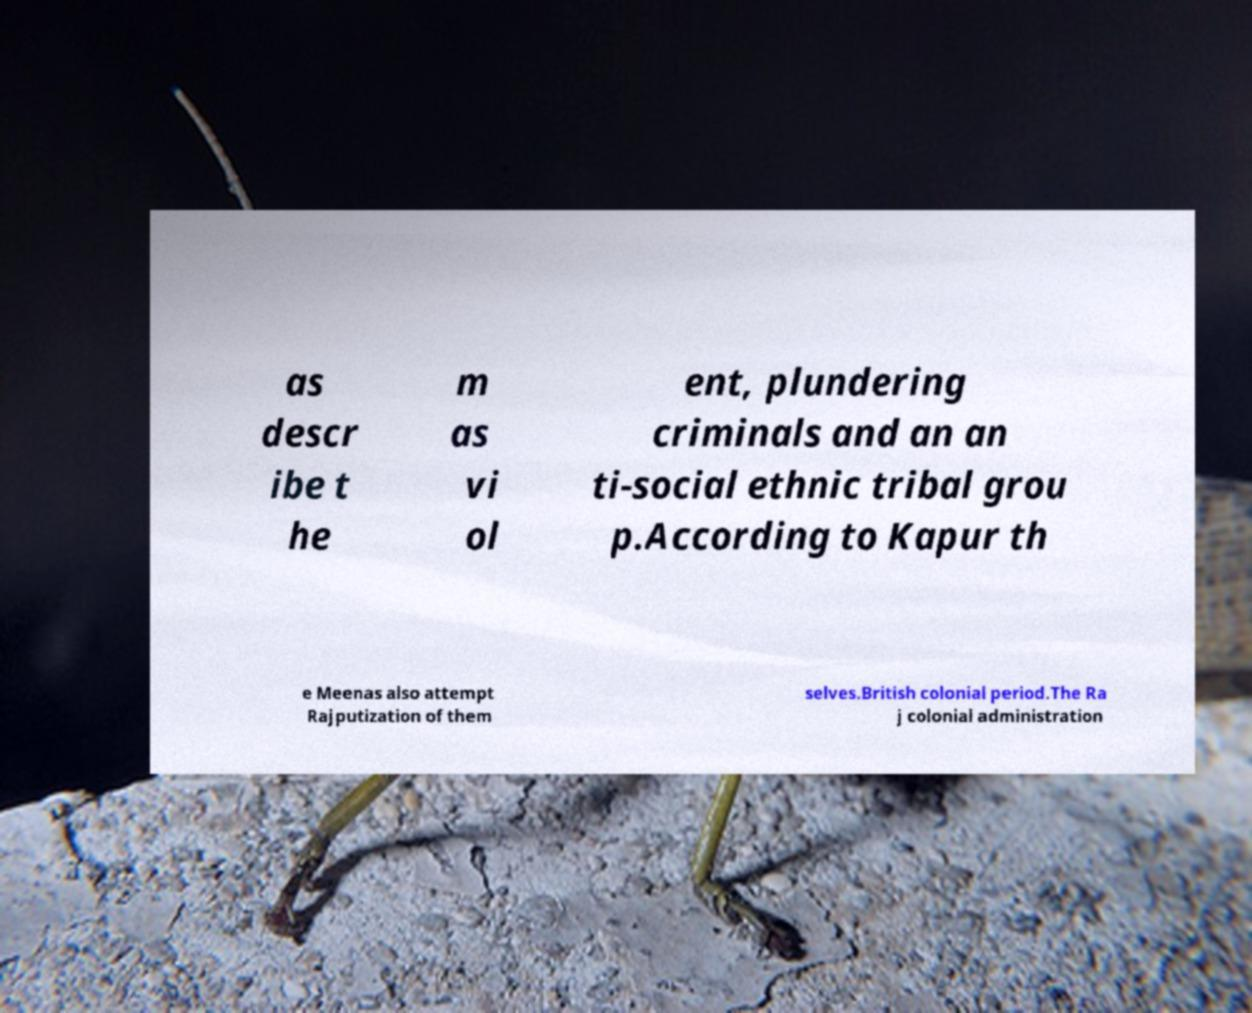Please read and relay the text visible in this image. What does it say? as descr ibe t he m as vi ol ent, plundering criminals and an an ti-social ethnic tribal grou p.According to Kapur th e Meenas also attempt Rajputization of them selves.British colonial period.The Ra j colonial administration 